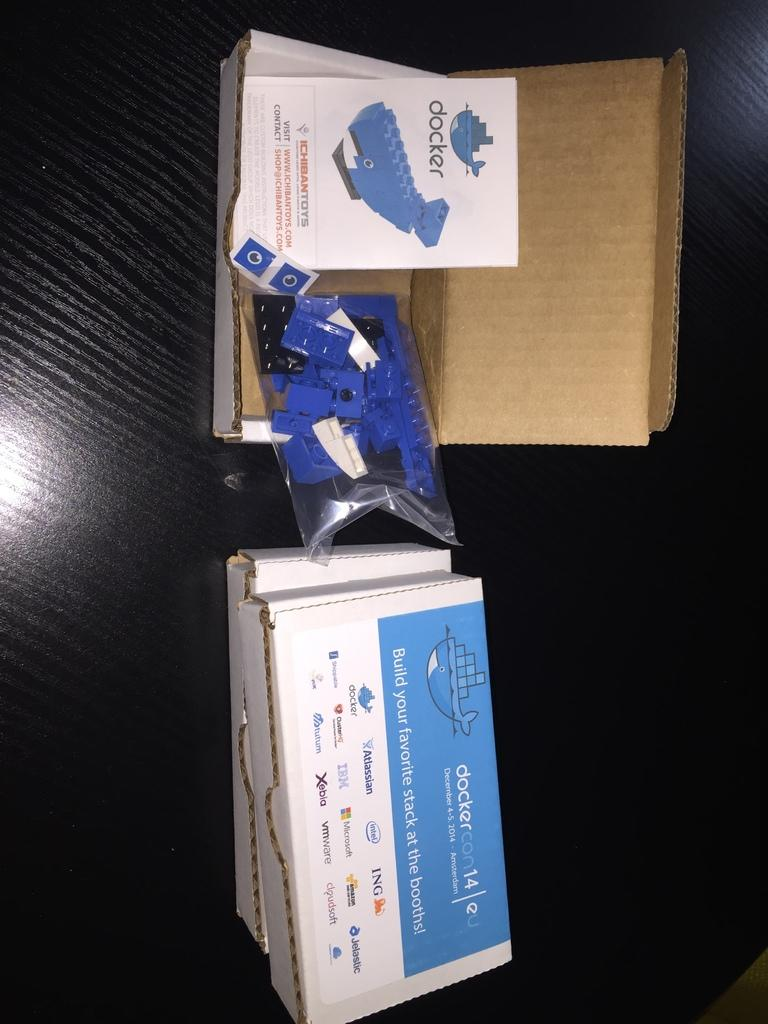<image>
Present a compact description of the photo's key features. A box that says docker on it contains a blue building brick whale. 